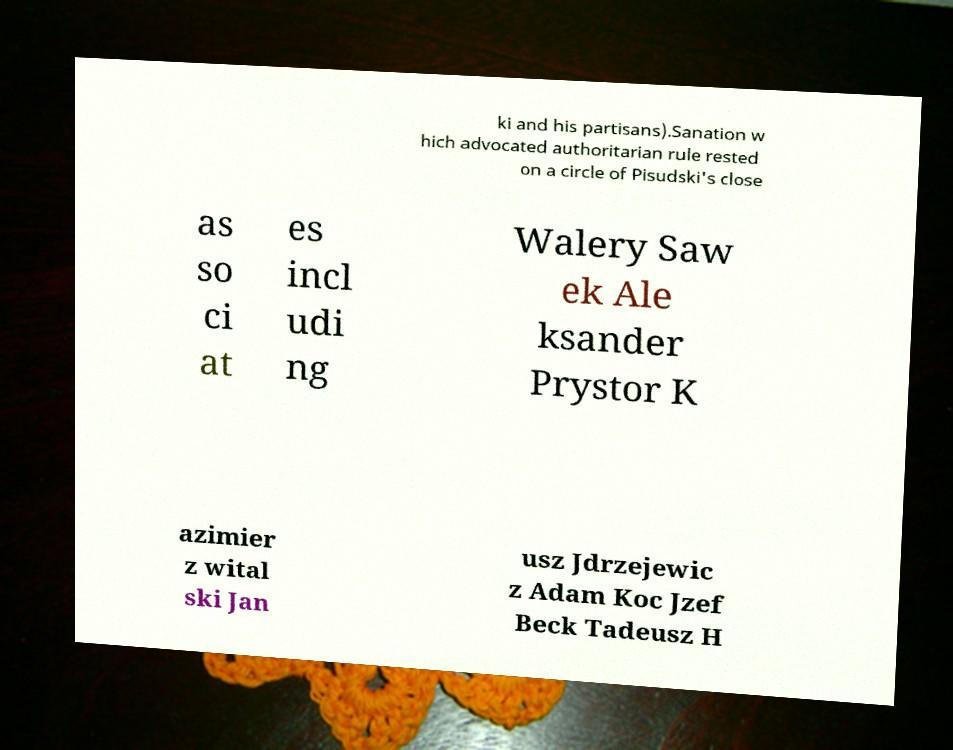Could you extract and type out the text from this image? ki and his partisans).Sanation w hich advocated authoritarian rule rested on a circle of Pisudski's close as so ci at es incl udi ng Walery Saw ek Ale ksander Prystor K azimier z wital ski Jan usz Jdrzejewic z Adam Koc Jzef Beck Tadeusz H 